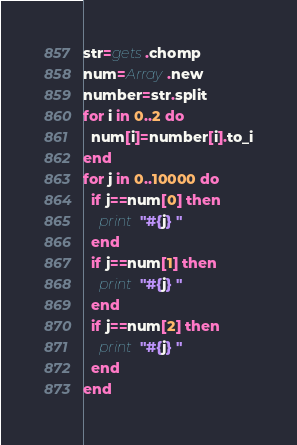<code> <loc_0><loc_0><loc_500><loc_500><_Ruby_>str=gets.chomp
num=Array.new
number=str.split
for i in 0..2 do
  num[i]=number[i].to_i
end
for j in 0..10000 do
  if j==num[0] then
    print "#{j} "
  end
  if j==num[1] then
    print "#{j} "
  end
  if j==num[2] then
    print "#{j} "
  end
end</code> 